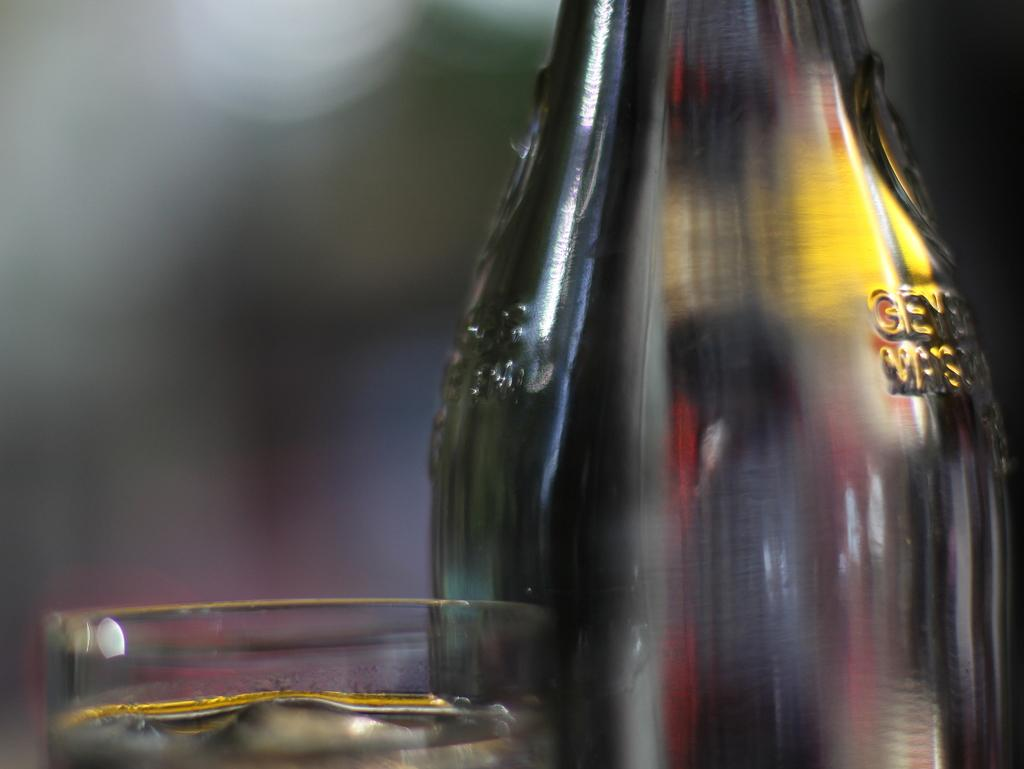What is in the glass that is visible in the image? There is a glass with water in the image. What other object can be seen in the image? There is a bottle in the image. Can you describe the background of the image? The background of the image is blurry. How many cherries are on the sock in the image? There is no sock or cherry present in the image. 